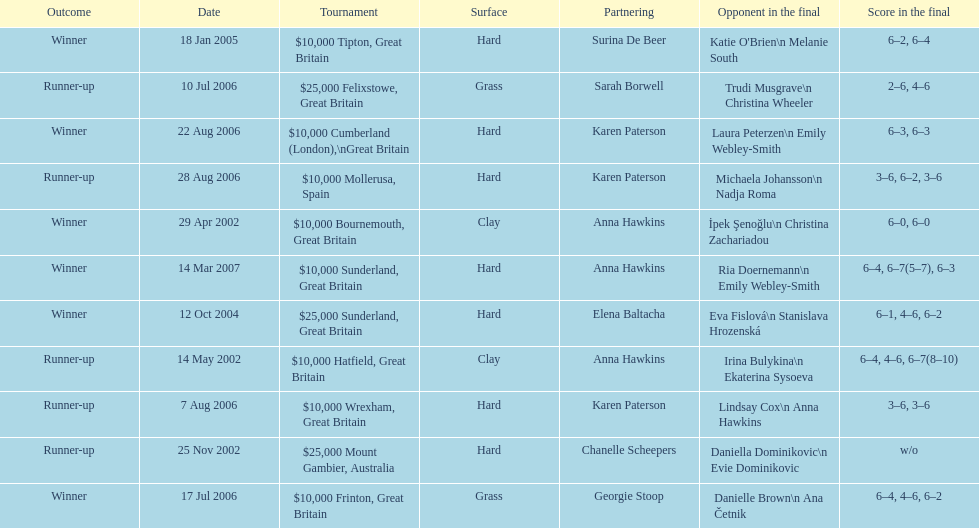What is the partnering name above chanelle scheepers? Anna Hawkins. 